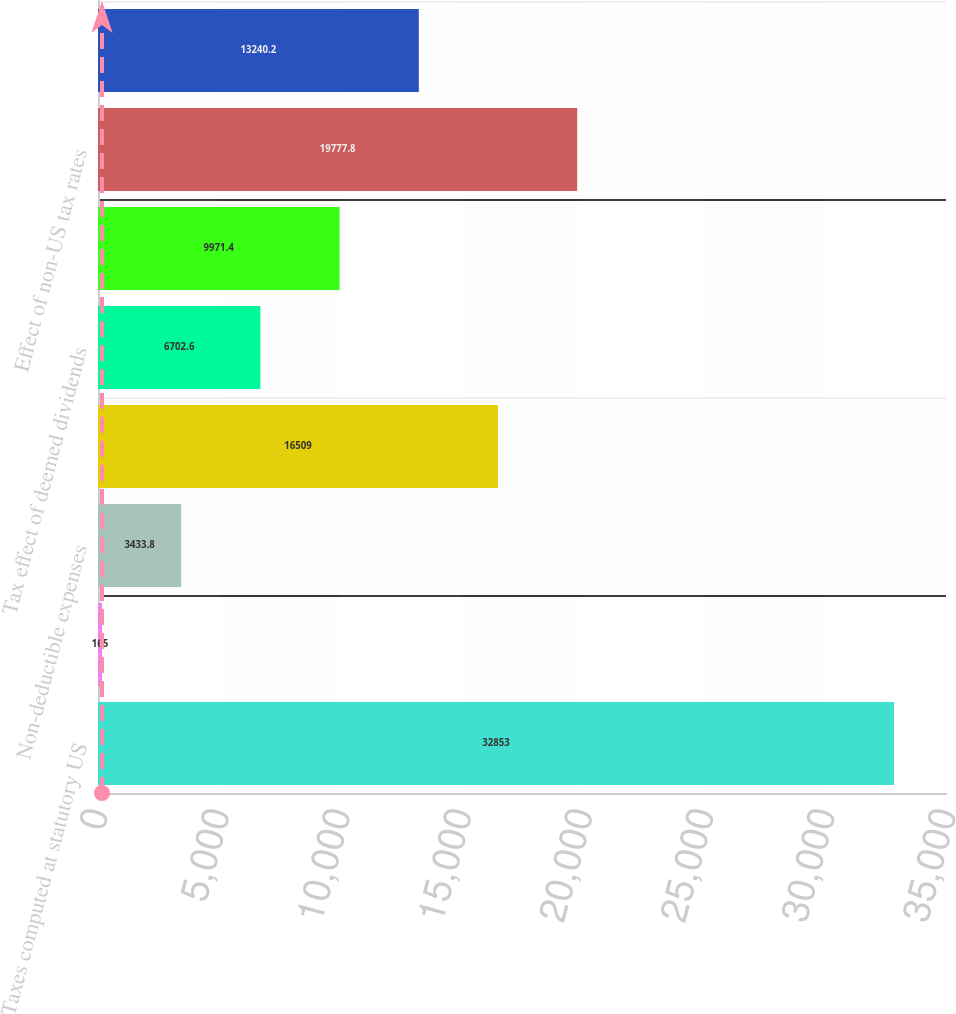Convert chart. <chart><loc_0><loc_0><loc_500><loc_500><bar_chart><fcel>Taxes computed at statutory US<fcel>State income taxes net of US<fcel>Non-deductible expenses<fcel>Research and development<fcel>Tax effect of deemed dividends<fcel>Change in valuation allowance<fcel>Effect of non-US tax rates<fcel>Other<nl><fcel>32853<fcel>165<fcel>3433.8<fcel>16509<fcel>6702.6<fcel>9971.4<fcel>19777.8<fcel>13240.2<nl></chart> 